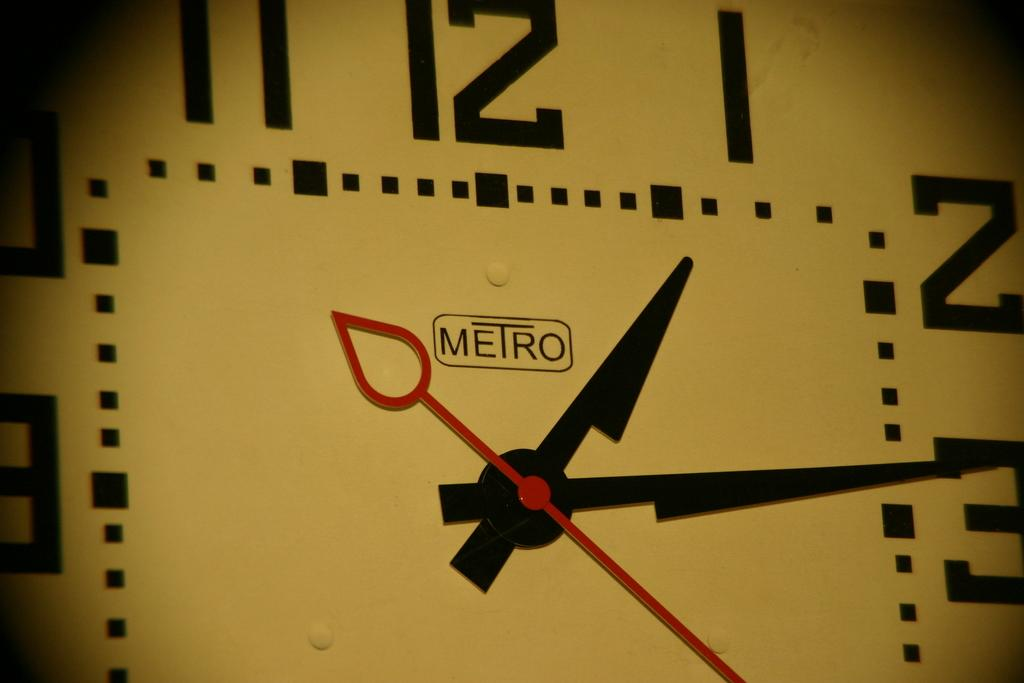<image>
Summarize the visual content of the image. An extreme close up of a Metro clock showing the time at nearly 1:15 